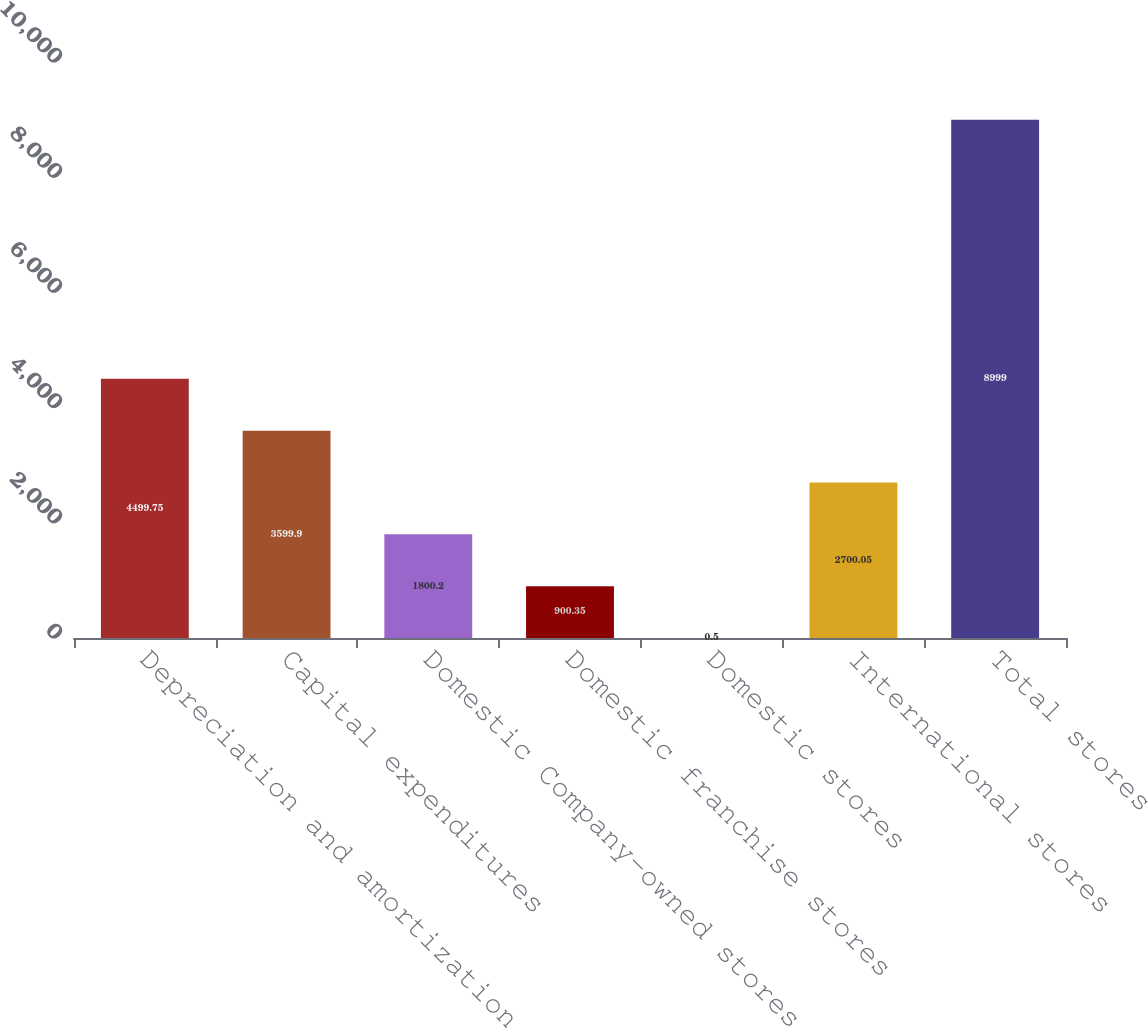Convert chart to OTSL. <chart><loc_0><loc_0><loc_500><loc_500><bar_chart><fcel>Depreciation and amortization<fcel>Capital expenditures<fcel>Domestic Company-owned stores<fcel>Domestic franchise stores<fcel>Domestic stores<fcel>International stores<fcel>Total stores<nl><fcel>4499.75<fcel>3599.9<fcel>1800.2<fcel>900.35<fcel>0.5<fcel>2700.05<fcel>8999<nl></chart> 